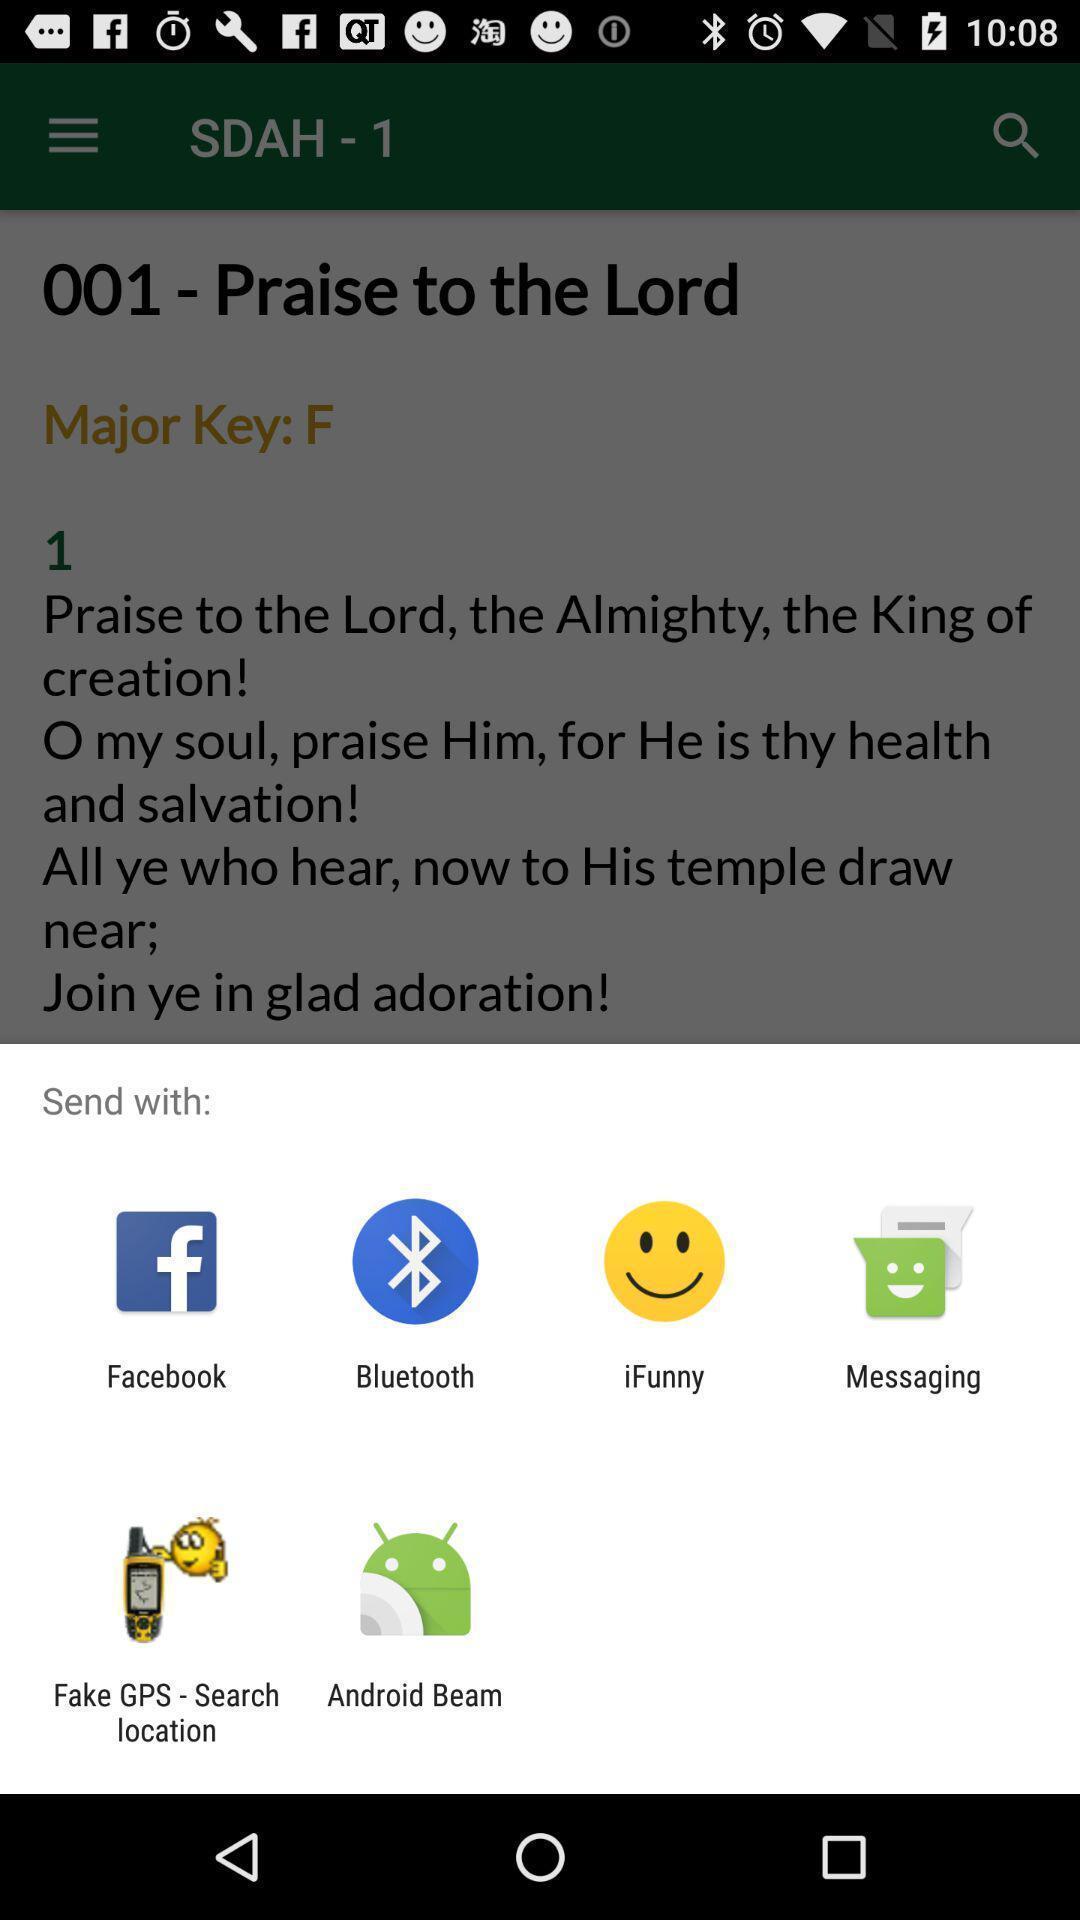Give me a narrative description of this picture. Pop-up shows send option with multiple apps. 